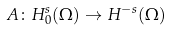Convert formula to latex. <formula><loc_0><loc_0><loc_500><loc_500>\ A \colon H ^ { s } _ { 0 } ( \Omega ) \to H ^ { - s } ( \Omega )</formula> 